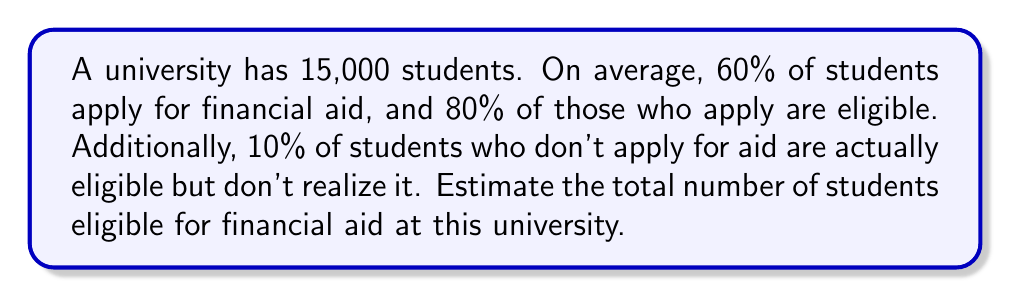Help me with this question. Let's break this down step-by-step:

1) First, calculate the number of students who apply for financial aid:
   $15,000 \times 60\% = 15,000 \times 0.60 = 9,000$ students apply

2) Of those who apply, calculate how many are eligible:
   $9,000 \times 80\% = 9,000 \times 0.80 = 7,200$ students are eligible from those who applied

3) Now, calculate the number of students who don't apply:
   $15,000 - 9,000 = 6,000$ students don't apply

4) Of those who don't apply, calculate how many are actually eligible:
   $6,000 \times 10\% = 6,000 \times 0.10 = 600$ students are eligible from those who didn't apply

5) Sum up the total number of eligible students:
   $7,200 + 600 = 7,800$ total eligible students

Therefore, we estimate that 7,800 students are eligible for financial aid at this university.
Answer: 7,800 students 